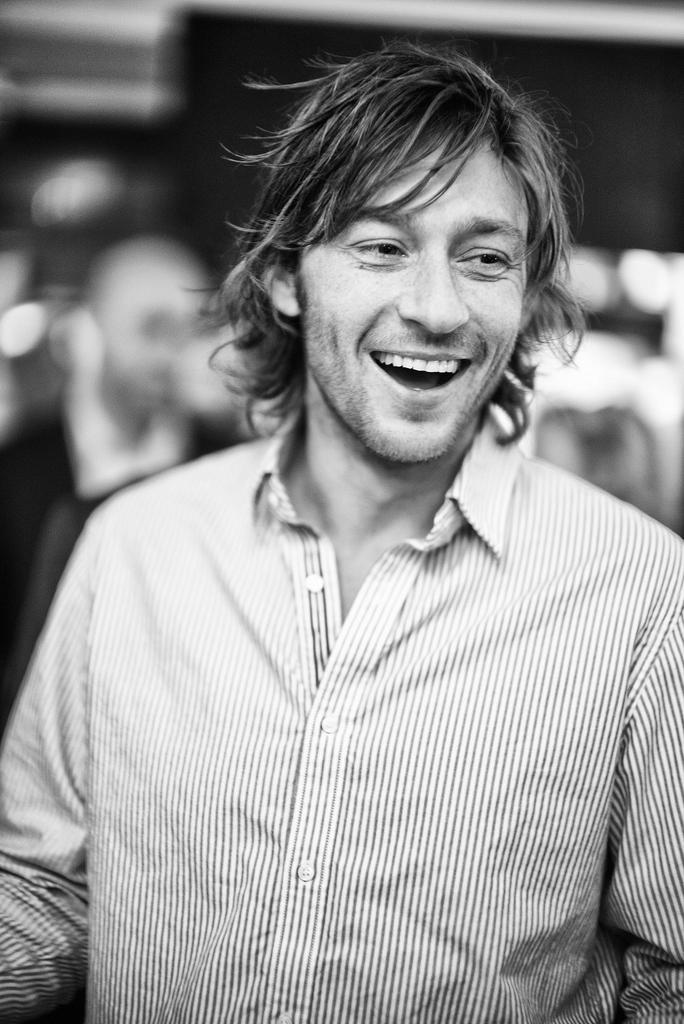Who is present in the image? There is a man in the image. What is the man's facial expression? The man is smiling. What is the color scheme of the image? The image is black and white. Can you describe the background of the image? The background of the image is blurred. What type of flag can be seen in the background of the image? There is no flag present in the image; it is a black and white image of a man smiling with a blurred background. 